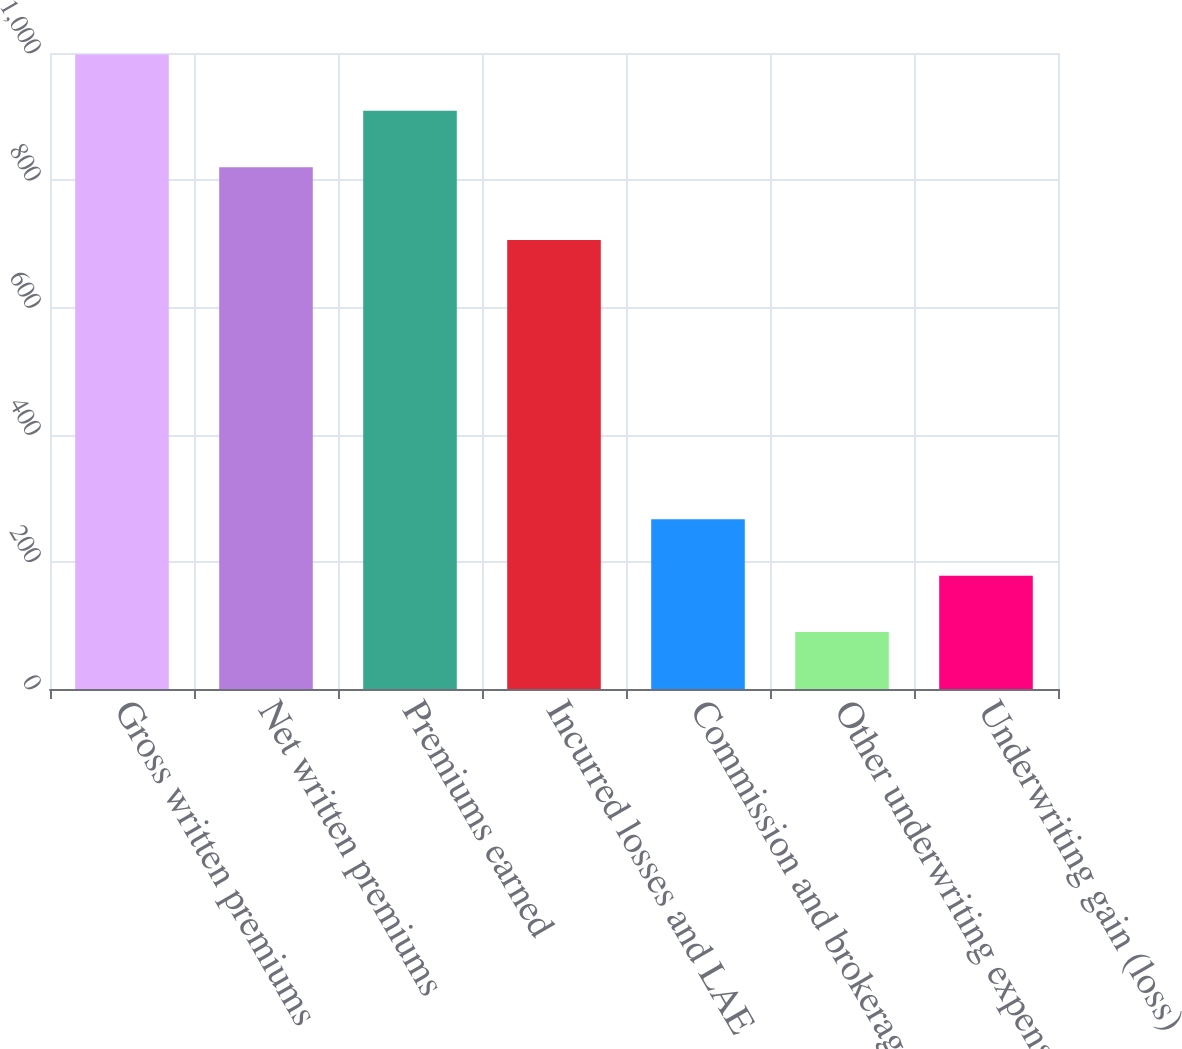Convert chart. <chart><loc_0><loc_0><loc_500><loc_500><bar_chart><fcel>Gross written premiums<fcel>Net written premiums<fcel>Premiums earned<fcel>Incurred losses and LAE<fcel>Commission and brokerage<fcel>Other underwriting expenses<fcel>Underwriting gain (loss)<nl><fcel>997.72<fcel>820.5<fcel>909.11<fcel>705.9<fcel>266.72<fcel>89.5<fcel>178.11<nl></chart> 